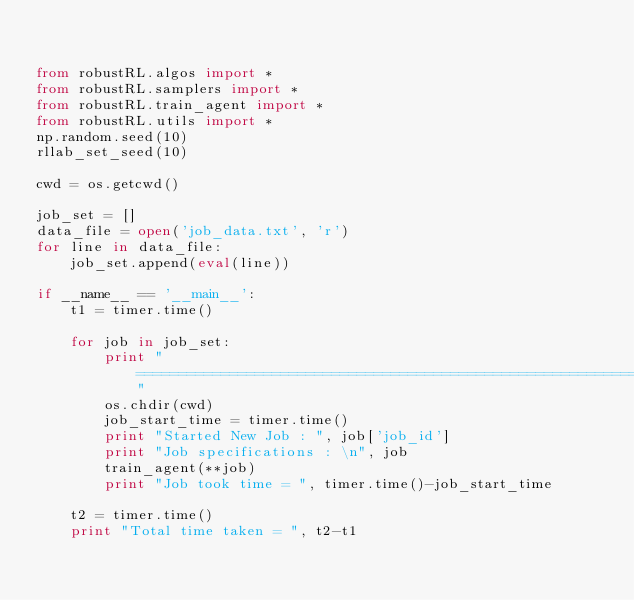<code> <loc_0><loc_0><loc_500><loc_500><_Python_>

from robustRL.algos import *
from robustRL.samplers import *
from robustRL.train_agent import *
from robustRL.utils import *
np.random.seed(10)
rllab_set_seed(10)

cwd = os.getcwd()

job_set = []
data_file = open('job_data.txt', 'r')
for line in data_file:
    job_set.append(eval(line))

if __name__ == '__main__':
    t1 = timer.time()

    for job in job_set:
        print " ============================================================"
        os.chdir(cwd)
        job_start_time = timer.time()
        print "Started New Job : ", job['job_id']
        print "Job specifications : \n", job
        train_agent(**job)
        print "Job took time = ", timer.time()-job_start_time

    t2 = timer.time()
    print "Total time taken = ", t2-t1</code> 